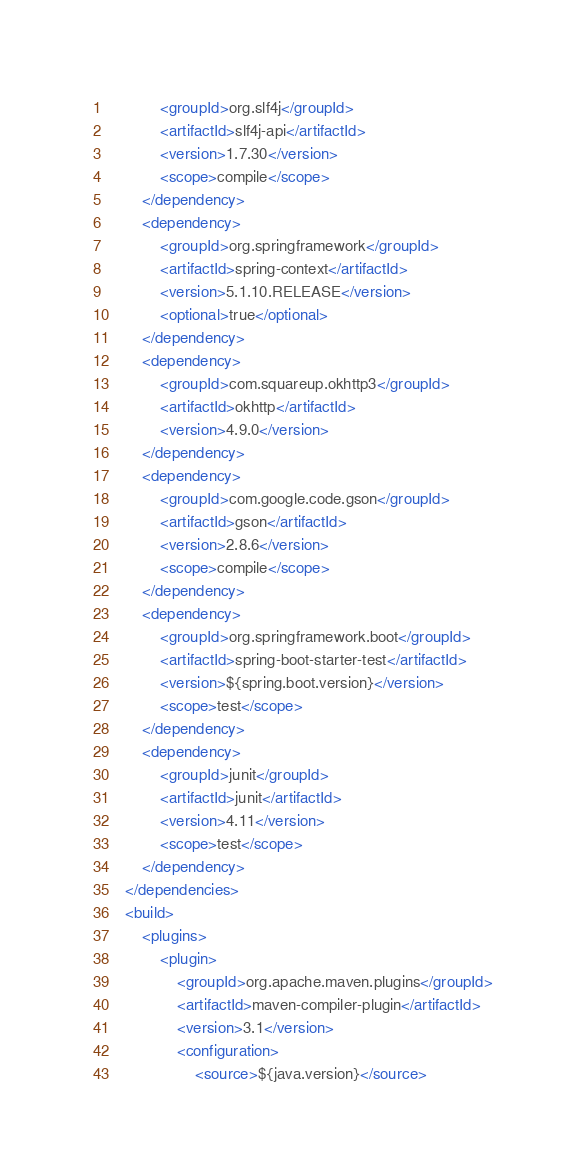Convert code to text. <code><loc_0><loc_0><loc_500><loc_500><_XML_>			<groupId>org.slf4j</groupId>
			<artifactId>slf4j-api</artifactId>
			<version>1.7.30</version>
			<scope>compile</scope>
		</dependency>
		<dependency>
			<groupId>org.springframework</groupId>
			<artifactId>spring-context</artifactId>
			<version>5.1.10.RELEASE</version>
			<optional>true</optional>
		</dependency>
		<dependency>
			<groupId>com.squareup.okhttp3</groupId>
			<artifactId>okhttp</artifactId>
			<version>4.9.0</version>
		</dependency>
		<dependency>
			<groupId>com.google.code.gson</groupId>
			<artifactId>gson</artifactId>
			<version>2.8.6</version>
			<scope>compile</scope>
		</dependency>
		<dependency>
			<groupId>org.springframework.boot</groupId>
			<artifactId>spring-boot-starter-test</artifactId>
			<version>${spring.boot.version}</version>
			<scope>test</scope>
		</dependency>
		<dependency>
			<groupId>junit</groupId>
			<artifactId>junit</artifactId>
			<version>4.11</version>
			<scope>test</scope>
		</dependency>
	</dependencies>
	<build>
		<plugins>
			<plugin>
				<groupId>org.apache.maven.plugins</groupId>
				<artifactId>maven-compiler-plugin</artifactId>
				<version>3.1</version>
				<configuration>
					<source>${java.version}</source></code> 